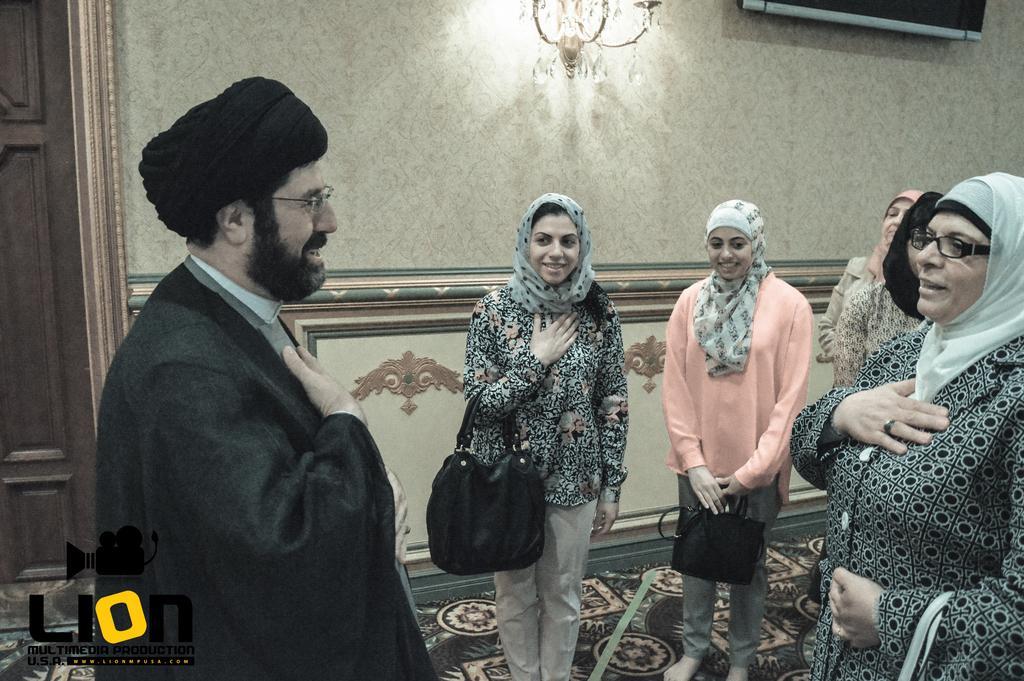In one or two sentences, can you explain what this image depicts? In this image I can see six persons are standing on the floor, logo and bags. In the background I can see a wall, door, chandelier and a screen. This image is taken may be in a hall. 